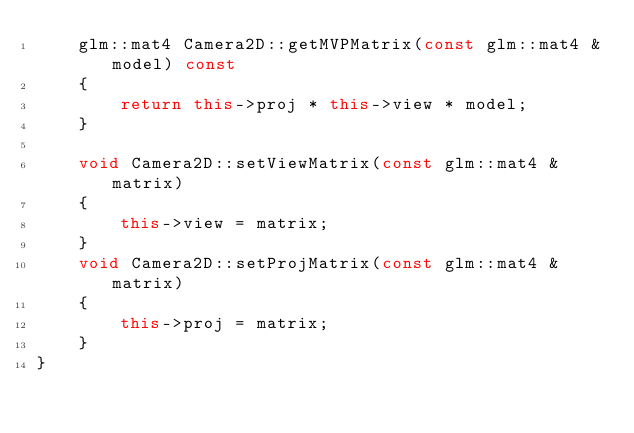Convert code to text. <code><loc_0><loc_0><loc_500><loc_500><_C++_>    glm::mat4 Camera2D::getMVPMatrix(const glm::mat4 &model) const
    {
        return this->proj * this->view * model;
    }
    
    void Camera2D::setViewMatrix(const glm::mat4 &matrix)
    {
        this->view = matrix;
    }
    void Camera2D::setProjMatrix(const glm::mat4 &matrix)
    {
        this->proj = matrix;
    }
}
</code> 